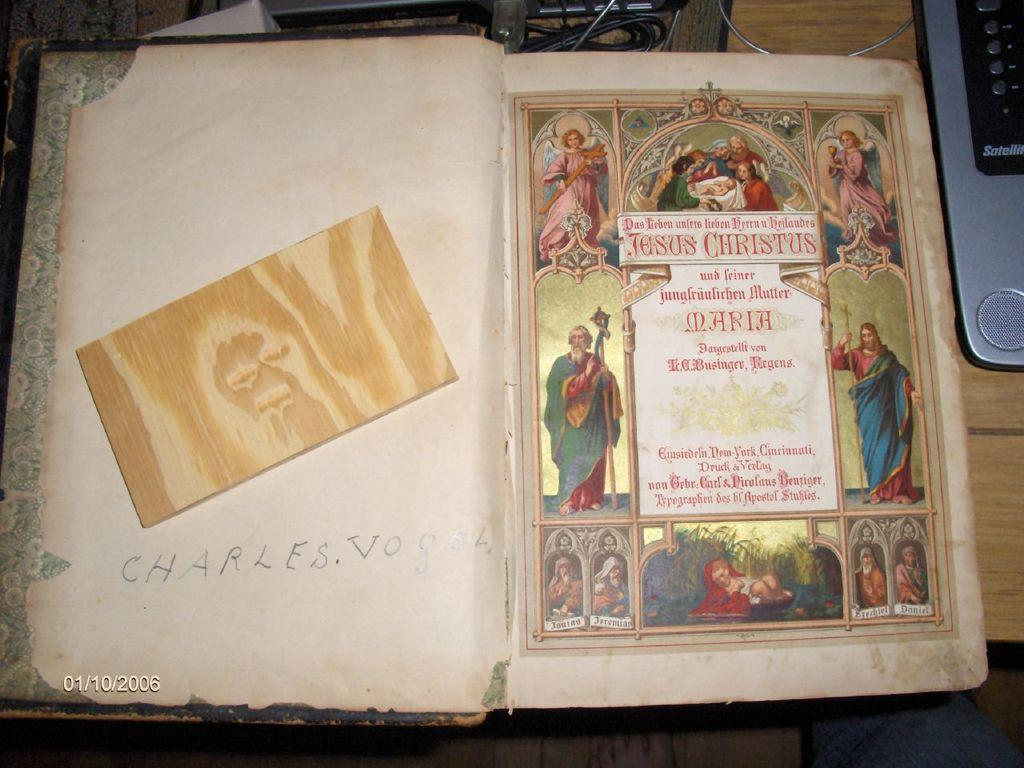<image>
Share a concise interpretation of the image provided. a open book that has the name Charles Vogel on the left 